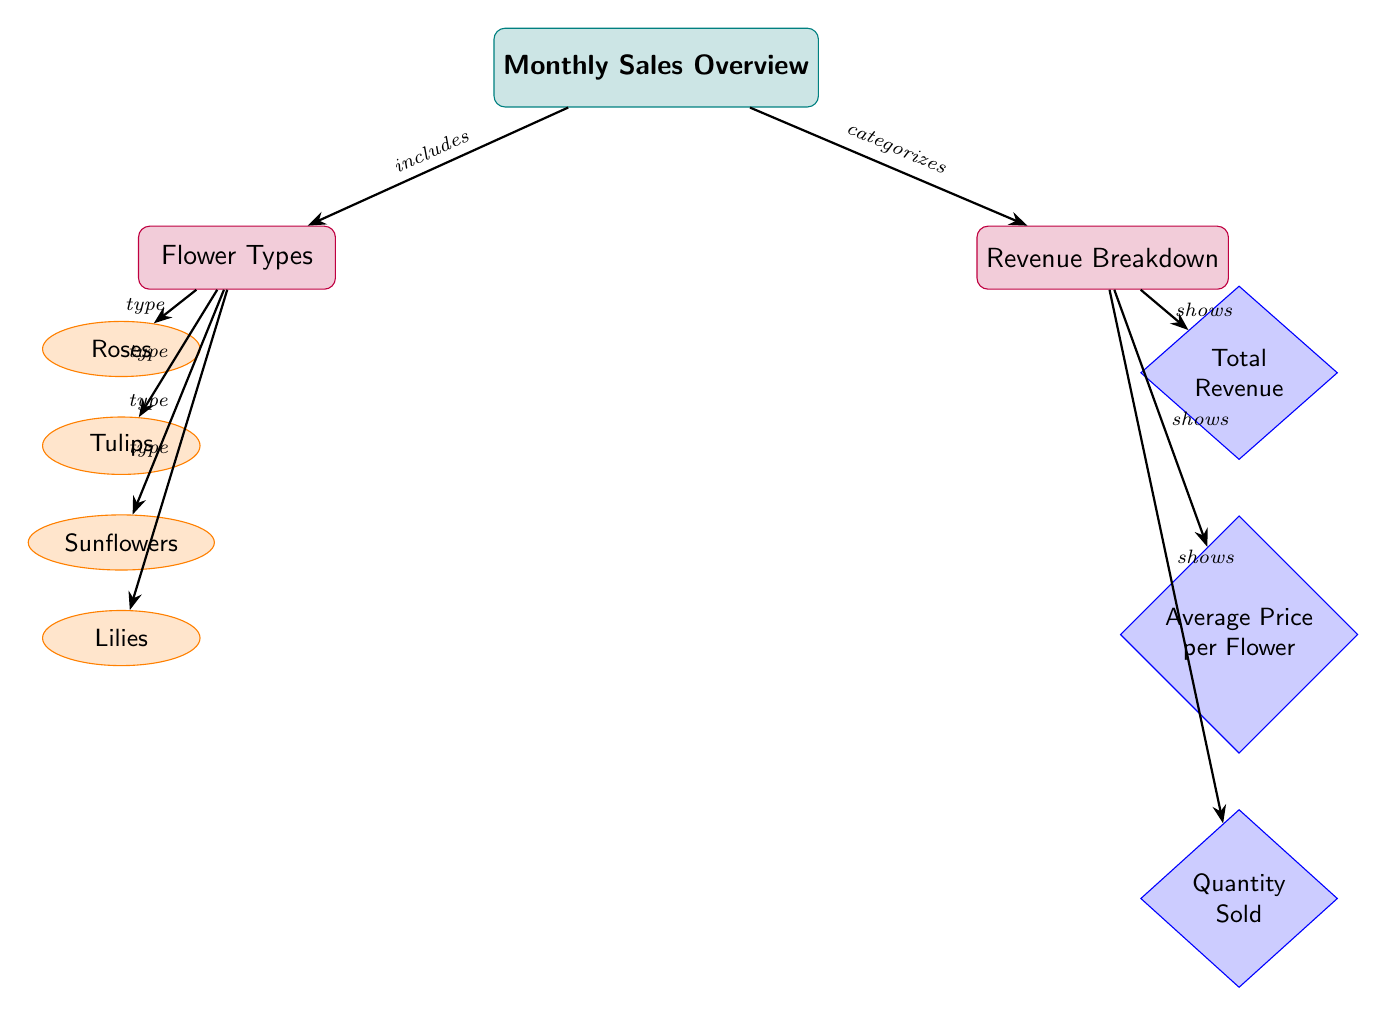What are the types of flowers included in the sales overview? The diagram lists four types of flowers under the "Flower Types" category: Roses, Tulips, Sunflowers, and Lilies. Since the question asks for the basic information contained within the diagram, we can directly see that these four types are explicitly mentioned under the relevant section.
Answer: Roses, Tulips, Sunflowers, Lilies How many revenue breakdown categories are shown? There are three categories under the "Revenue Breakdown": Total Revenue, Average Price per Flower, and Quantity Sold. The diagram clearly outlines these categories, allowing us to count them easily.
Answer: 3 Which flower type is associated with the node directly related to the total revenue? The total revenue node in the "Revenue Breakdown" category does not have a direct flower associated with it. Instead, it aggregates revenue without tying back to a specific flower type. However, the diagram indicates that all flower types contribute to the total revenue. Therefore, no specific type is exclusively associated with the total revenue.
Answer: None What relationship do the types of flowers have with the monthly sales overview? The types of flowers have the relationship of “includes” with the monthly sales overview as shown by the arrow linking the "Sales Overview" to the "Flower Types" category. This signifies that all types are a part of the sales analysis.
Answer: Includes What direction do the arrows indicating the flow of information between "Revenue Breakdown" and its categories go? Each arrow points downward from the "Revenue Breakdown" to its three categories: Total Revenue, Average Price per Flower, and Quantity Sold. This visualization indicates a hierarchical structure where information is categorized under the broader revenue breakdown. Following the arrows helps to trace this flow.
Answer: Downward 